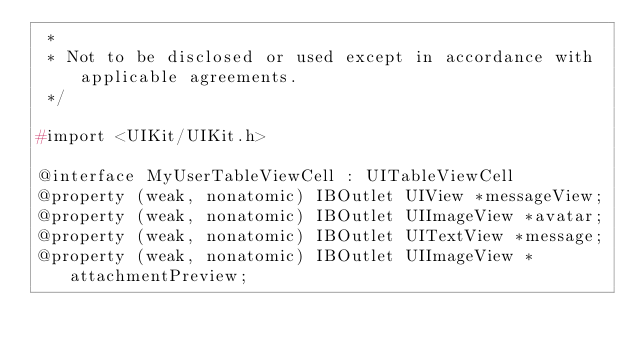Convert code to text. <code><loc_0><loc_0><loc_500><loc_500><_C_> *
 * Not to be disclosed or used except in accordance with applicable agreements.
 */

#import <UIKit/UIKit.h>

@interface MyUserTableViewCell : UITableViewCell
@property (weak, nonatomic) IBOutlet UIView *messageView;
@property (weak, nonatomic) IBOutlet UIImageView *avatar;
@property (weak, nonatomic) IBOutlet UITextView *message;
@property (weak, nonatomic) IBOutlet UIImageView *attachmentPreview;</code> 